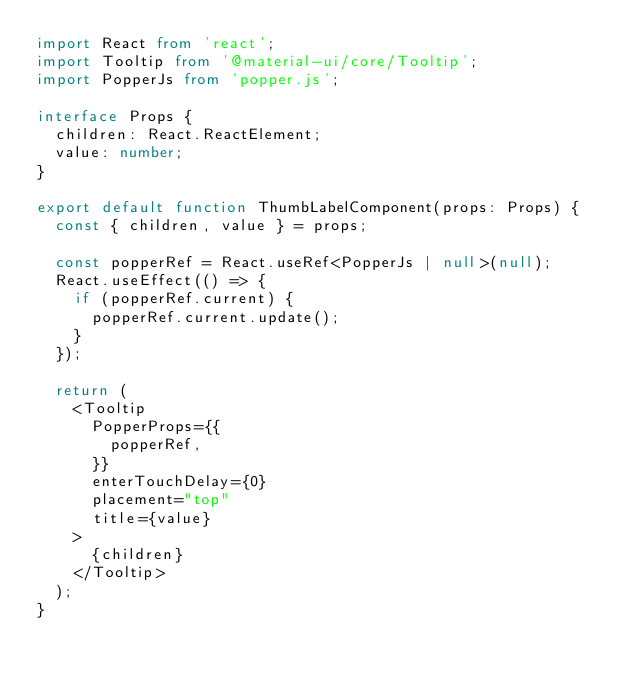<code> <loc_0><loc_0><loc_500><loc_500><_TypeScript_>import React from 'react';
import Tooltip from '@material-ui/core/Tooltip';
import PopperJs from 'popper.js';

interface Props {
  children: React.ReactElement;
  value: number;
}

export default function ThumbLabelComponent(props: Props) {
  const { children, value } = props;

  const popperRef = React.useRef<PopperJs | null>(null);
  React.useEffect(() => {
    if (popperRef.current) {
      popperRef.current.update();
    }
  });

  return (
    <Tooltip
      PopperProps={{
        popperRef,
      }}
      enterTouchDelay={0}
      placement="top"
      title={value}
    >
      {children}
    </Tooltip>
  );
}
</code> 